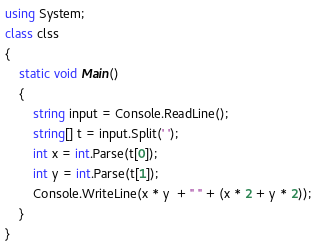<code> <loc_0><loc_0><loc_500><loc_500><_C#_>using System;
class clss
{
    static void Main()
    {
        string input = Console.ReadLine();
        string[] t = input.Split(' ');
        int x = int.Parse(t[0]);
        int y = int.Parse(t[1]);
        Console.WriteLine(x * y  + " " + (x * 2 + y * 2));
    }
}</code> 